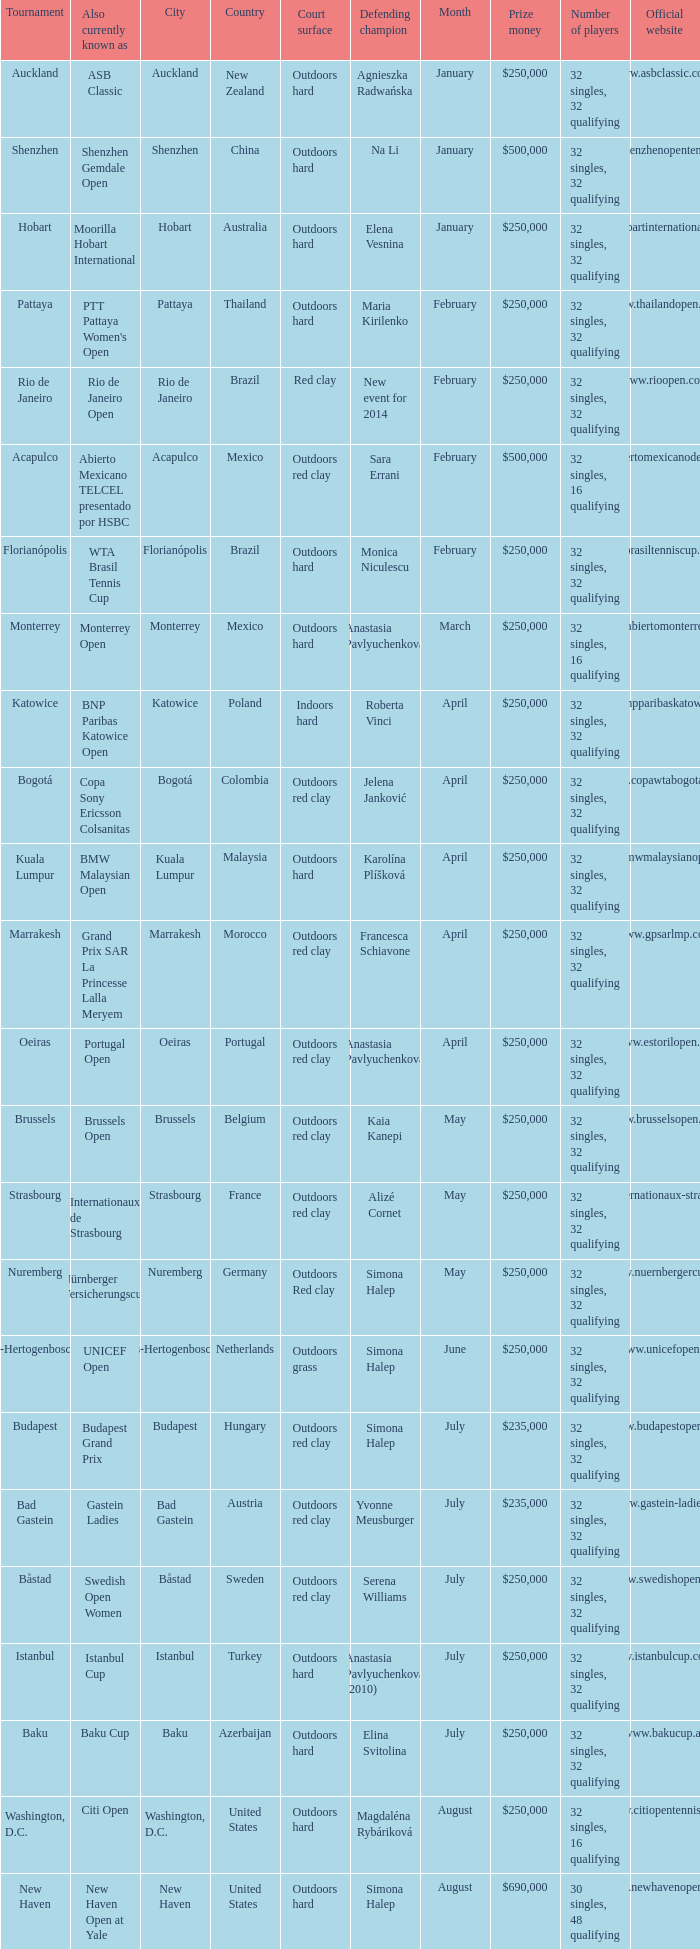How many defending champs from thailand? 1.0. 